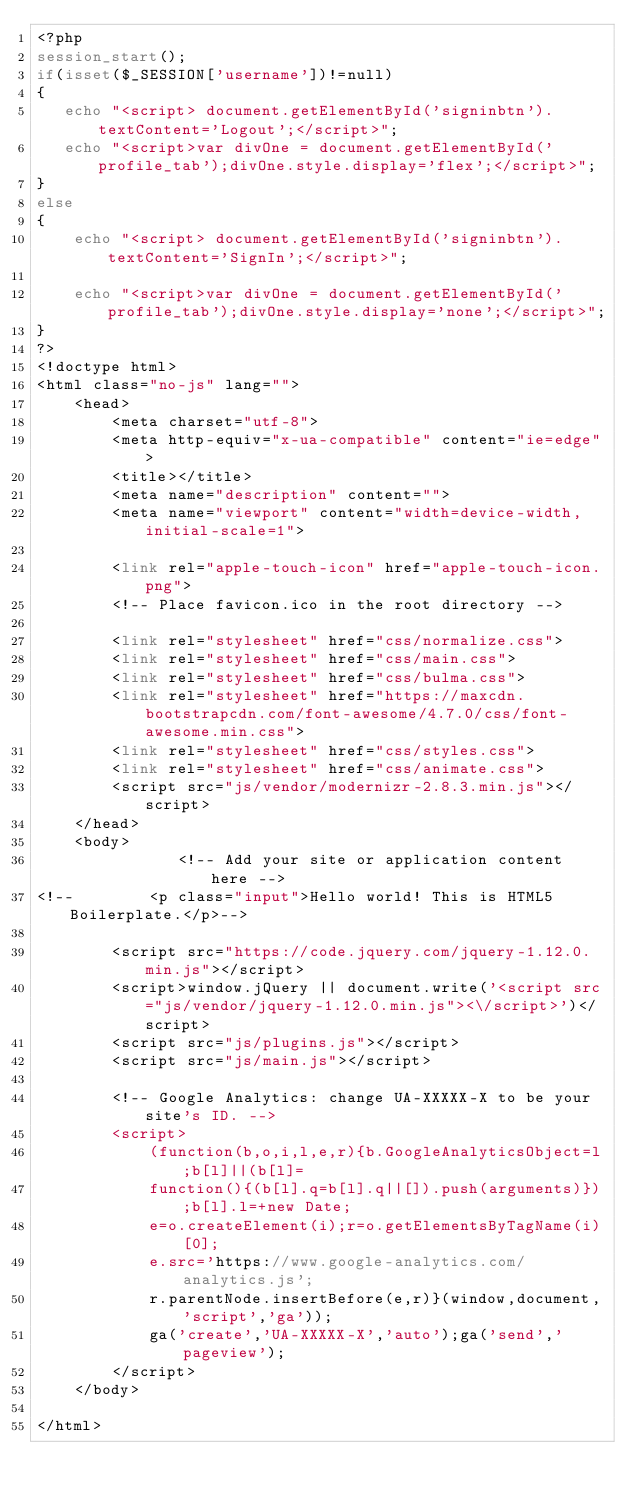Convert code to text. <code><loc_0><loc_0><loc_500><loc_500><_PHP_><?php
session_start();
if(isset($_SESSION['username'])!=null)
{
   echo "<script> document.getElementById('signinbtn').textContent='Logout';</script>";
   echo "<script>var divOne = document.getElementById('profile_tab');divOne.style.display='flex';</script>";
}
else
{
    echo "<script> document.getElementById('signinbtn').textContent='SignIn';</script>";

    echo "<script>var divOne = document.getElementById('profile_tab');divOne.style.display='none';</script>";
}
?>
<!doctype html>
<html class="no-js" lang="">
    <head>
        <meta charset="utf-8">
        <meta http-equiv="x-ua-compatible" content="ie=edge">
        <title></title>
        <meta name="description" content="">
        <meta name="viewport" content="width=device-width, initial-scale=1">

        <link rel="apple-touch-icon" href="apple-touch-icon.png">
        <!-- Place favicon.ico in the root directory -->

        <link rel="stylesheet" href="css/normalize.css">
        <link rel="stylesheet" href="css/main.css">
        <link rel="stylesheet" href="css/bulma.css">
        <link rel="stylesheet" href="https://maxcdn.bootstrapcdn.com/font-awesome/4.7.0/css/font-awesome.min.css">
        <link rel="stylesheet" href="css/styles.css">
        <link rel="stylesheet" href="css/animate.css">
        <script src="js/vendor/modernizr-2.8.3.min.js"></script>
    </head>
    <body>
               <!-- Add your site or application content here -->
<!--        <p class="input">Hello world! This is HTML5 Boilerplate.</p>-->

        <script src="https://code.jquery.com/jquery-1.12.0.min.js"></script>
        <script>window.jQuery || document.write('<script src="js/vendor/jquery-1.12.0.min.js"><\/script>')</script>
        <script src="js/plugins.js"></script>
        <script src="js/main.js"></script>

        <!-- Google Analytics: change UA-XXXXX-X to be your site's ID. -->
        <script>
            (function(b,o,i,l,e,r){b.GoogleAnalyticsObject=l;b[l]||(b[l]=
            function(){(b[l].q=b[l].q||[]).push(arguments)});b[l].l=+new Date;
            e=o.createElement(i);r=o.getElementsByTagName(i)[0];
            e.src='https://www.google-analytics.com/analytics.js';
            r.parentNode.insertBefore(e,r)}(window,document,'script','ga'));
            ga('create','UA-XXXXX-X','auto');ga('send','pageview');
        </script>
    </body>

</html>
</code> 